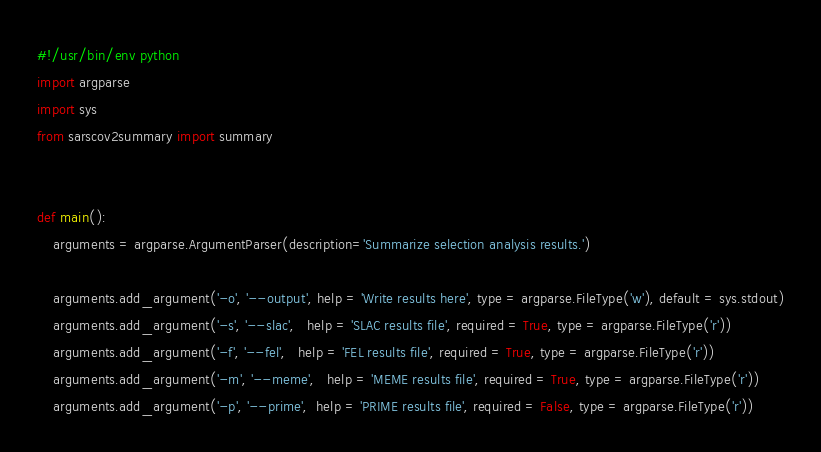Convert code to text. <code><loc_0><loc_0><loc_500><loc_500><_Python_>#!/usr/bin/env python
import argparse
import sys
from sarscov2summary import summary


def main():
	arguments = argparse.ArgumentParser(description='Summarize selection analysis results.')

	arguments.add_argument('-o', '--output', help = 'Write results here', type = argparse.FileType('w'), default = sys.stdout)
	arguments.add_argument('-s', '--slac',   help = 'SLAC results file', required = True, type = argparse.FileType('r'))
	arguments.add_argument('-f', '--fel',   help = 'FEL results file', required = True, type = argparse.FileType('r'))
	arguments.add_argument('-m', '--meme',   help = 'MEME results file', required = True, type = argparse.FileType('r'))
	arguments.add_argument('-p', '--prime',  help = 'PRIME results file', required = False, type = argparse.FileType('r'))</code> 